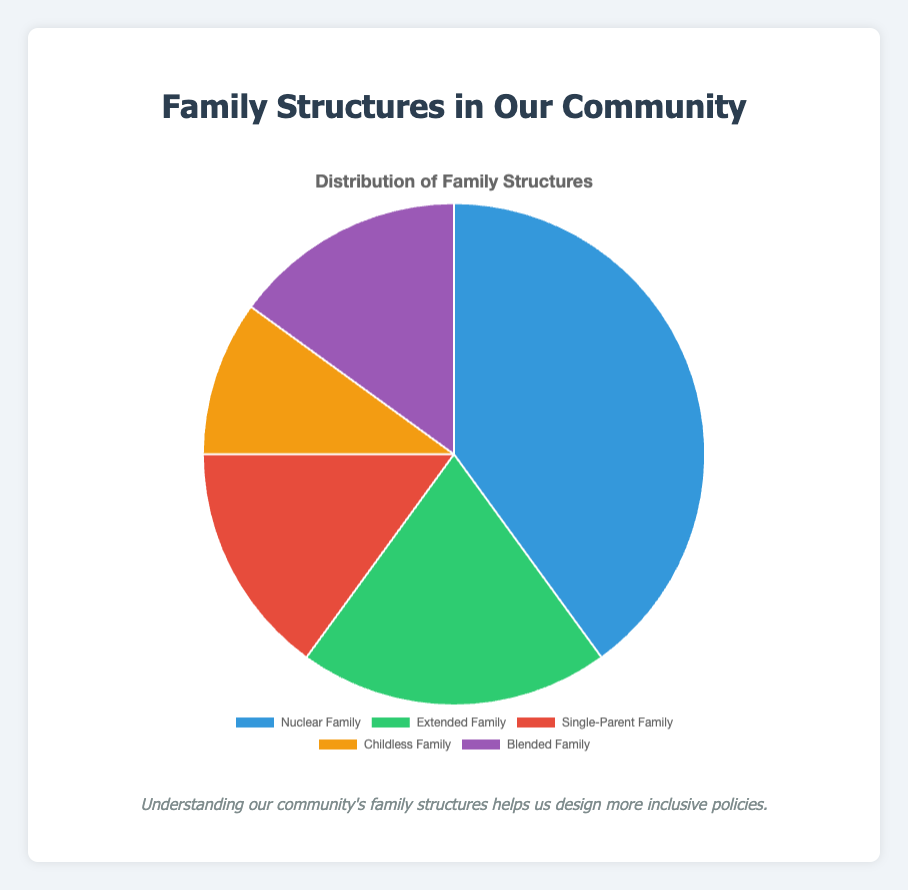What percentage of families in the community are single-parent families? The chart shows a section labeled "Single-Parent Family" with the percentage associated with it.
Answer: 15% Which type of family structure is the most common in the community? The largest section of the pie chart represents the most common family structure, indicated by the percentage.
Answer: Nuclear Family How do the percentages of blended families and single-parent families compare? Both the blended families and single-parent families have the same percentage value, as indicated by the size of their sections and the numerical labels.
Answer: They are equal What is the total percentage of families that are either nuclear families or extended families? Add the percentages of nuclear families (40%) and extended families (20%): 40 + 20 = 60.
Answer: 60% Which family structure represents the smallest group in the community? Find the section with the smallest percentage. The childless family section has the lowest percentage.
Answer: Childless Family By how much does the percentage of nuclear families exceed the percentage of extended families? Subtract the percentage of extended families (20%) from nuclear families (40%): 40 - 20 = 20.
Answer: 20% What is the combined percentage of childless families and blended families? Add the percentages of childless families (10%) and blended families (15%): 10 + 15 = 25.
Answer: 25% Which family structure is represented by the color blue in the chart? Identify the section colored blue and read its label.
Answer: Nuclear Family Compare the visual sizes of the sections representing single-parent families and childless families. The section representing single-parent families is larger than the section representing childless families, indicating a higher percentage.
Answer: Single-parent families' section is larger What is the average percentage of extended families, single-parent families, and childless families? Add the percentages of extended families (20%), single-parent families (15%), and childless families (10%) and divide by 3: (20 + 15 + 10) / 3 = 15.
Answer: 15% 